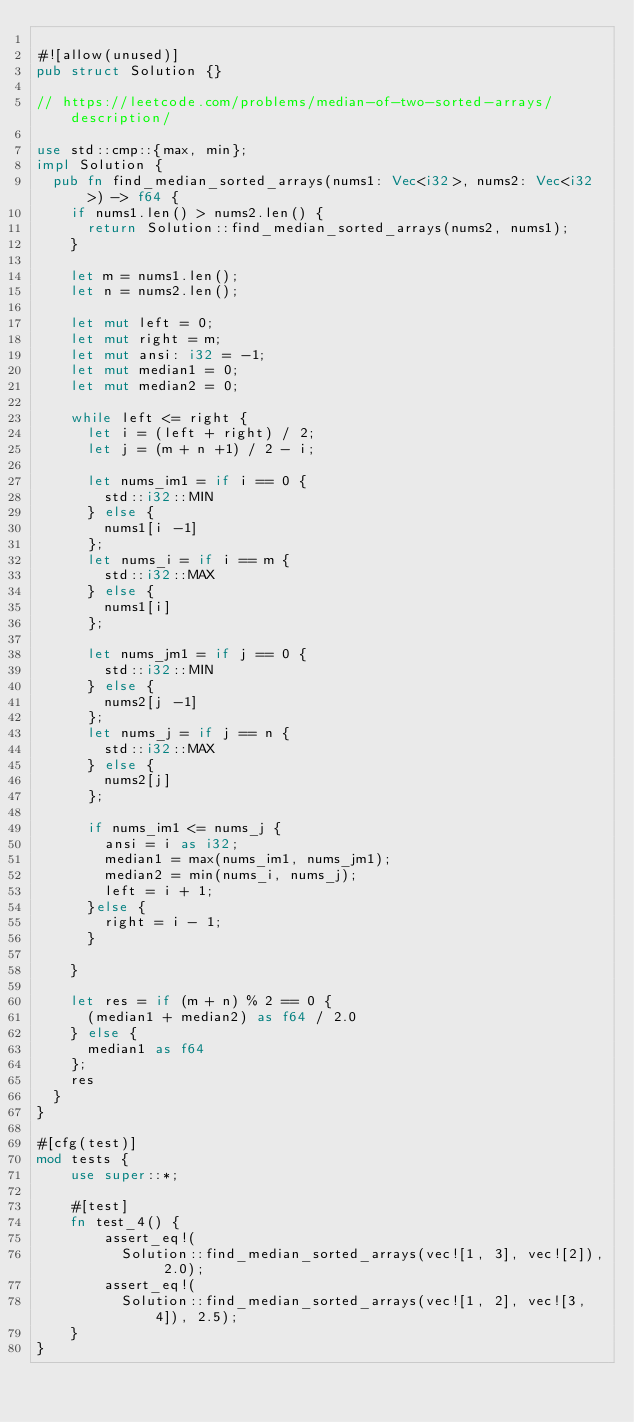<code> <loc_0><loc_0><loc_500><loc_500><_Rust_>
#![allow(unused)]
pub struct Solution {}

// https://leetcode.com/problems/median-of-two-sorted-arrays/description/

use std::cmp::{max, min};
impl Solution {
  pub fn find_median_sorted_arrays(nums1: Vec<i32>, nums2: Vec<i32>) -> f64 {
    if nums1.len() > nums2.len() {
      return Solution::find_median_sorted_arrays(nums2, nums1);
    }

    let m = nums1.len();
    let n = nums2.len();

    let mut left = 0;
    let mut right = m;
    let mut ansi: i32 = -1;
    let mut median1 = 0;
    let mut median2 = 0;

    while left <= right {
      let i = (left + right) / 2;
      let j = (m + n +1) / 2 - i;

      let nums_im1 = if i == 0 {
        std::i32::MIN
      } else {
        nums1[i -1]
      };
      let nums_i = if i == m {
        std::i32::MAX
      } else {
        nums1[i]
      };

      let nums_jm1 = if j == 0 {
        std::i32::MIN
      } else {
        nums2[j -1]
      };
      let nums_j = if j == n {
        std::i32::MAX
      } else {
        nums2[j]
      };
      
      if nums_im1 <= nums_j {
        ansi = i as i32;
        median1 = max(nums_im1, nums_jm1);
        median2 = min(nums_i, nums_j);
        left = i + 1;
      }else {
        right = i - 1;
      }

    }

    let res = if (m + n) % 2 == 0 {
      (median1 + median2) as f64 / 2.0 
    } else {
      median1 as f64
    };
    res
  }
}

#[cfg(test)]
mod tests {
    use super::*;

    #[test]
    fn test_4() {
        assert_eq!(
          Solution::find_median_sorted_arrays(vec![1, 3], vec![2]), 2.0);
        assert_eq!(
          Solution::find_median_sorted_arrays(vec![1, 2], vec![3, 4]), 2.5);
    }
}
</code> 